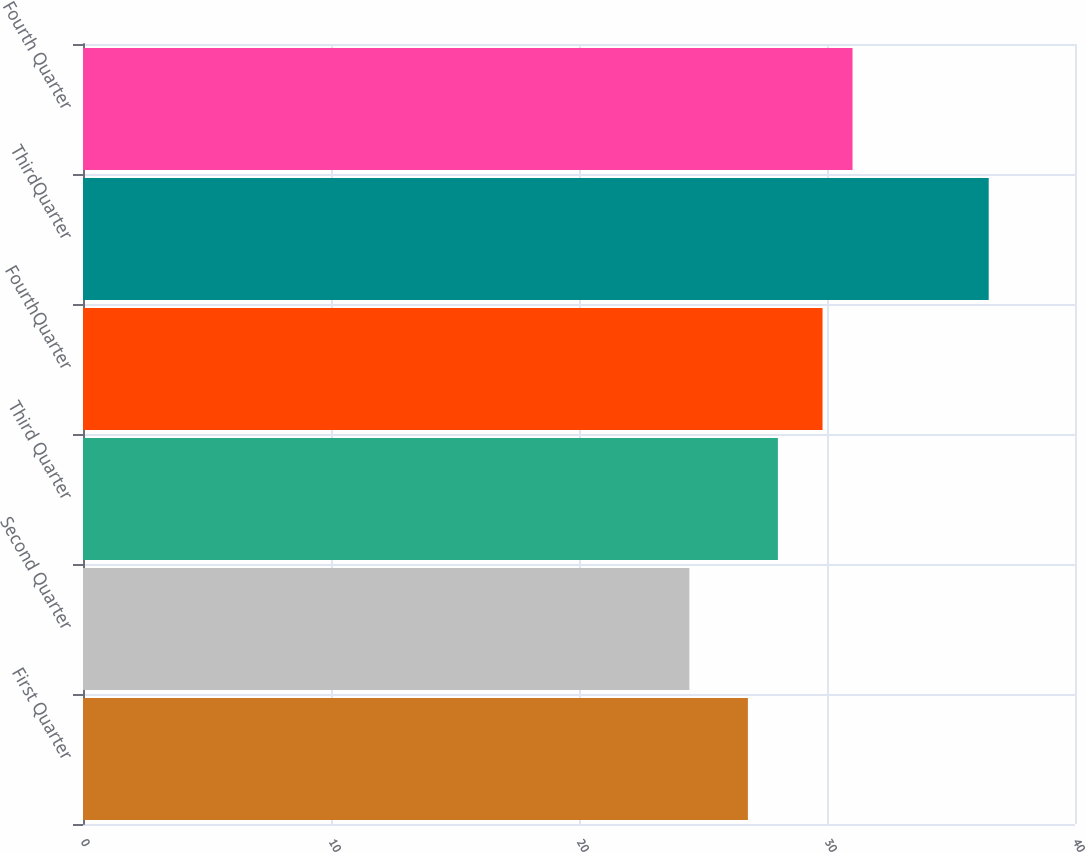Convert chart. <chart><loc_0><loc_0><loc_500><loc_500><bar_chart><fcel>First Quarter<fcel>Second Quarter<fcel>Third Quarter<fcel>FourthQuarter<fcel>ThirdQuarter<fcel>Fourth Quarter<nl><fcel>26.81<fcel>24.45<fcel>28.02<fcel>29.82<fcel>36.52<fcel>31.03<nl></chart> 